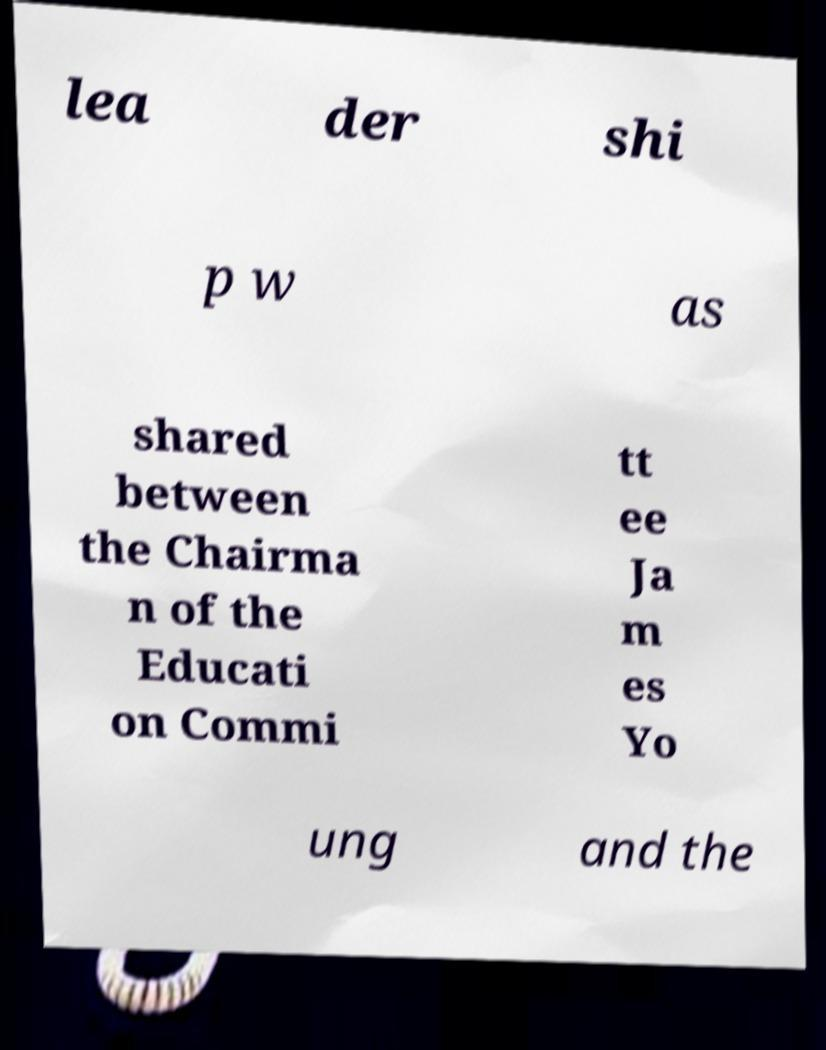Could you extract and type out the text from this image? lea der shi p w as shared between the Chairma n of the Educati on Commi tt ee Ja m es Yo ung and the 